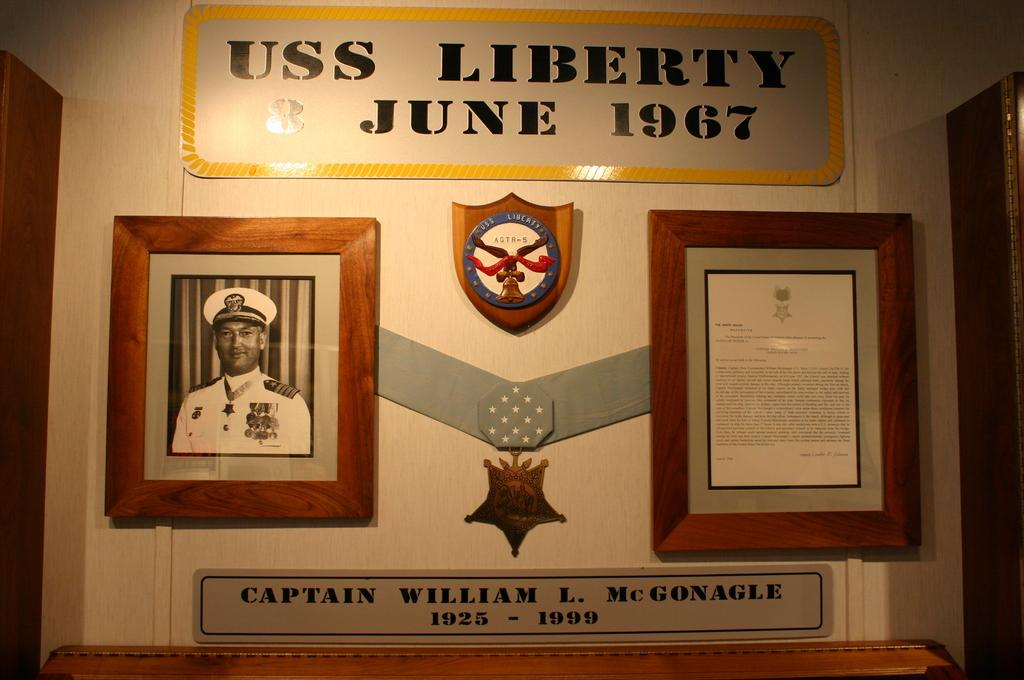<image>
Present a compact description of the photo's key features. A plaque on the wall for Captain William L. McGonagle describes his time with USS Liberty in June 1967. 